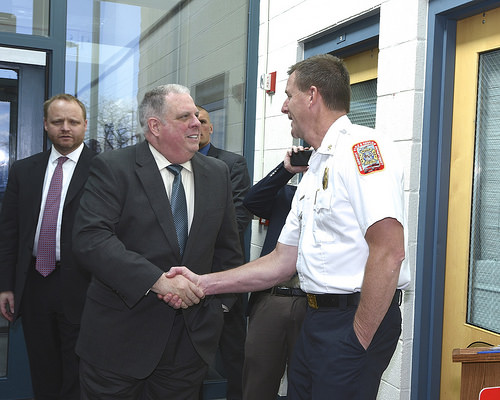<image>
Is there a tie on the guard? No. The tie is not positioned on the guard. They may be near each other, but the tie is not supported by or resting on top of the guard. Where is the police officer in relation to the man? Is it to the left of the man? No. The police officer is not to the left of the man. From this viewpoint, they have a different horizontal relationship. 